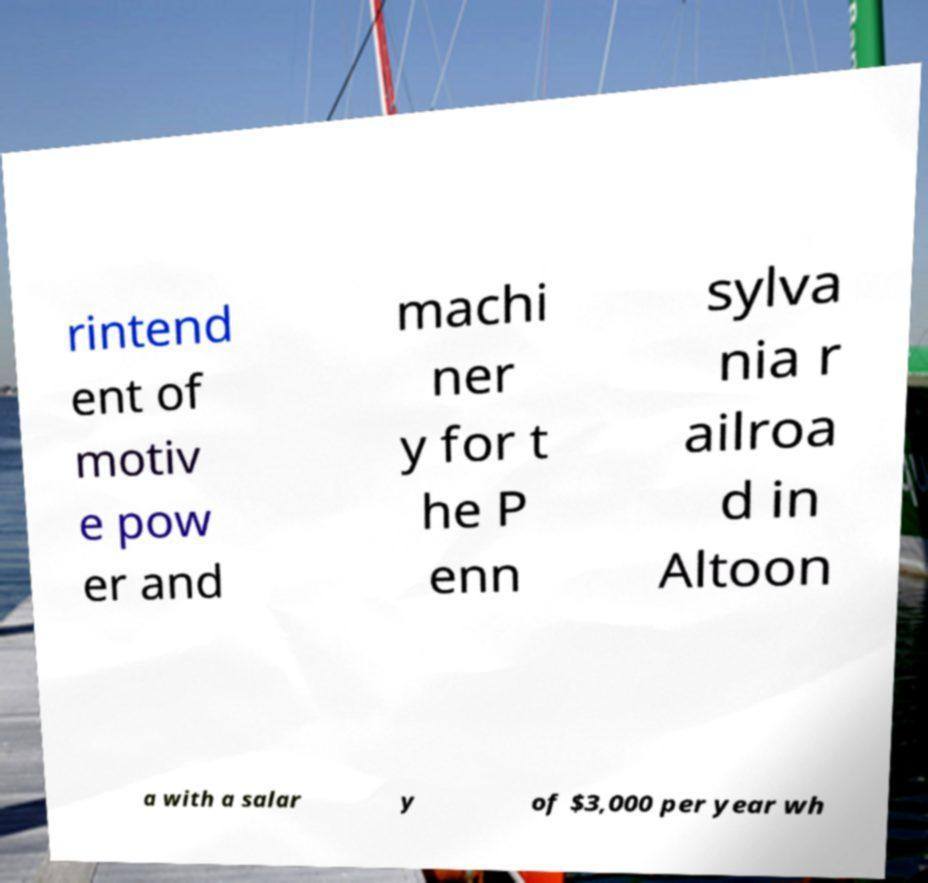Could you extract and type out the text from this image? rintend ent of motiv e pow er and machi ner y for t he P enn sylva nia r ailroa d in Altoon a with a salar y of $3,000 per year wh 